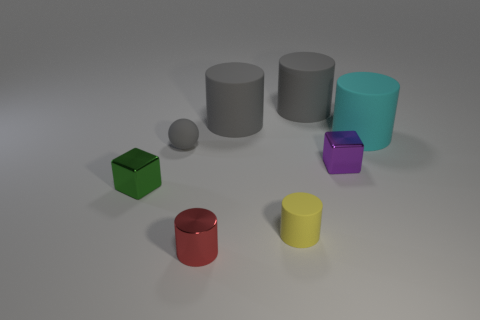Is the number of small metal cubes behind the purple cube less than the number of shiny things behind the cyan matte object?
Keep it short and to the point. No. What color is the small rubber sphere?
Provide a succinct answer. Gray. Are there any small matte cylinders of the same color as the ball?
Offer a terse response. No. There is a metallic object that is in front of the small block that is to the left of the small shiny block that is to the right of the tiny ball; what shape is it?
Your answer should be compact. Cylinder. What is the small block on the left side of the tiny purple shiny object made of?
Keep it short and to the point. Metal. What size is the matte cylinder that is behind the big rubber object that is left of the big gray object right of the yellow rubber object?
Your answer should be compact. Large. There is a red cylinder; is it the same size as the rubber cylinder that is left of the small yellow cylinder?
Provide a short and direct response. No. What is the color of the rubber cylinder in front of the gray ball?
Your response must be concise. Yellow. There is a small gray object to the right of the tiny green cube; what shape is it?
Ensure brevity in your answer.  Sphere. How many gray objects are either balls or small cylinders?
Offer a very short reply. 1. 